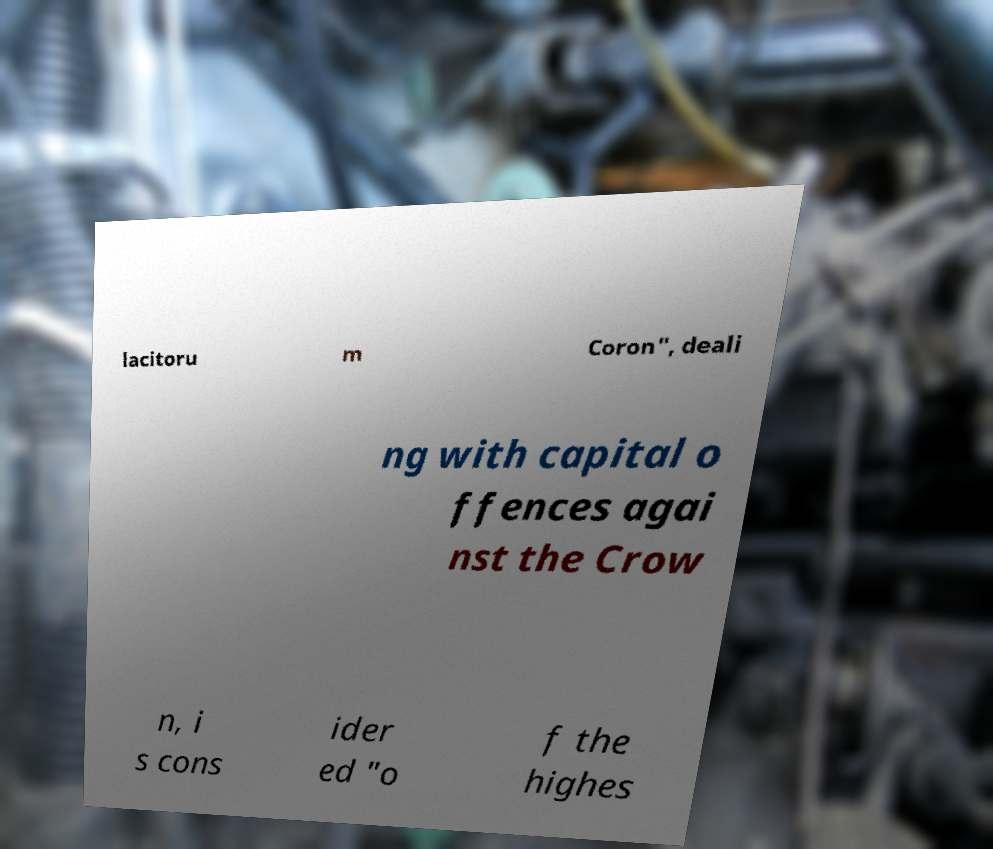Could you assist in decoding the text presented in this image and type it out clearly? lacitoru m Coron", deali ng with capital o ffences agai nst the Crow n, i s cons ider ed "o f the highes 